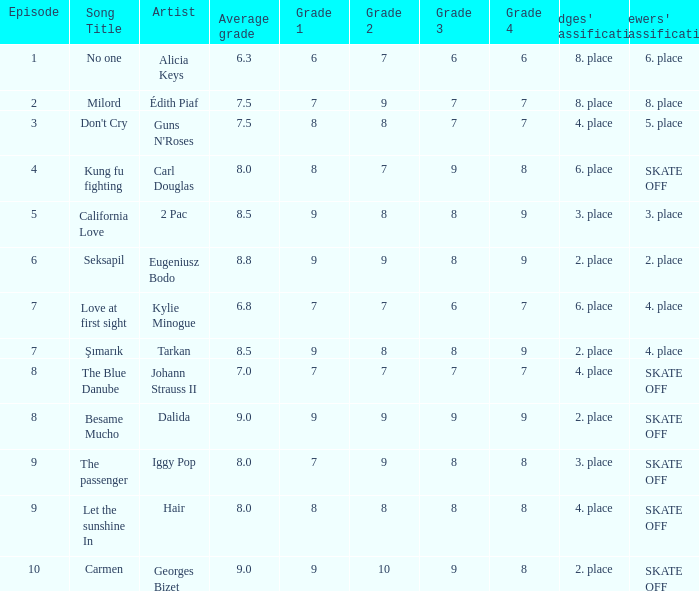Name the average grade for şımarık tarkan 8.5. 